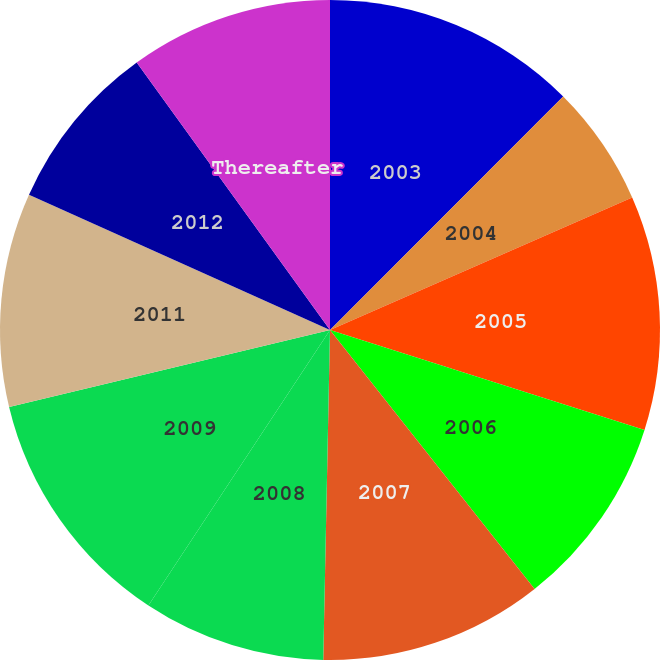Convert chart. <chart><loc_0><loc_0><loc_500><loc_500><pie_chart><fcel>2003<fcel>2004<fcel>2005<fcel>2006<fcel>2007<fcel>2008<fcel>2009<fcel>2011<fcel>2012<fcel>Thereafter<nl><fcel>12.49%<fcel>5.93%<fcel>11.48%<fcel>9.46%<fcel>10.97%<fcel>8.95%<fcel>11.98%<fcel>10.47%<fcel>8.32%<fcel>9.96%<nl></chart> 